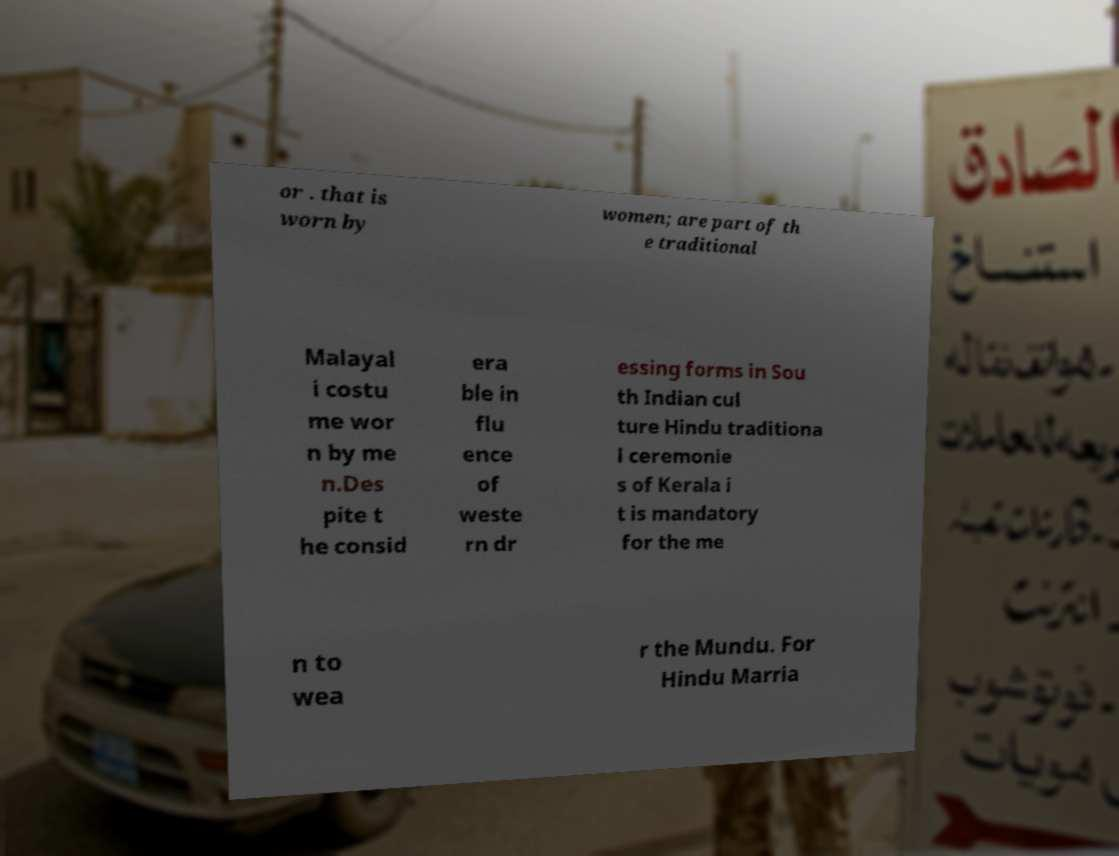Could you assist in decoding the text presented in this image and type it out clearly? or . that is worn by women; are part of th e traditional Malayal i costu me wor n by me n.Des pite t he consid era ble in flu ence of weste rn dr essing forms in Sou th Indian cul ture Hindu traditiona l ceremonie s of Kerala i t is mandatory for the me n to wea r the Mundu. For Hindu Marria 